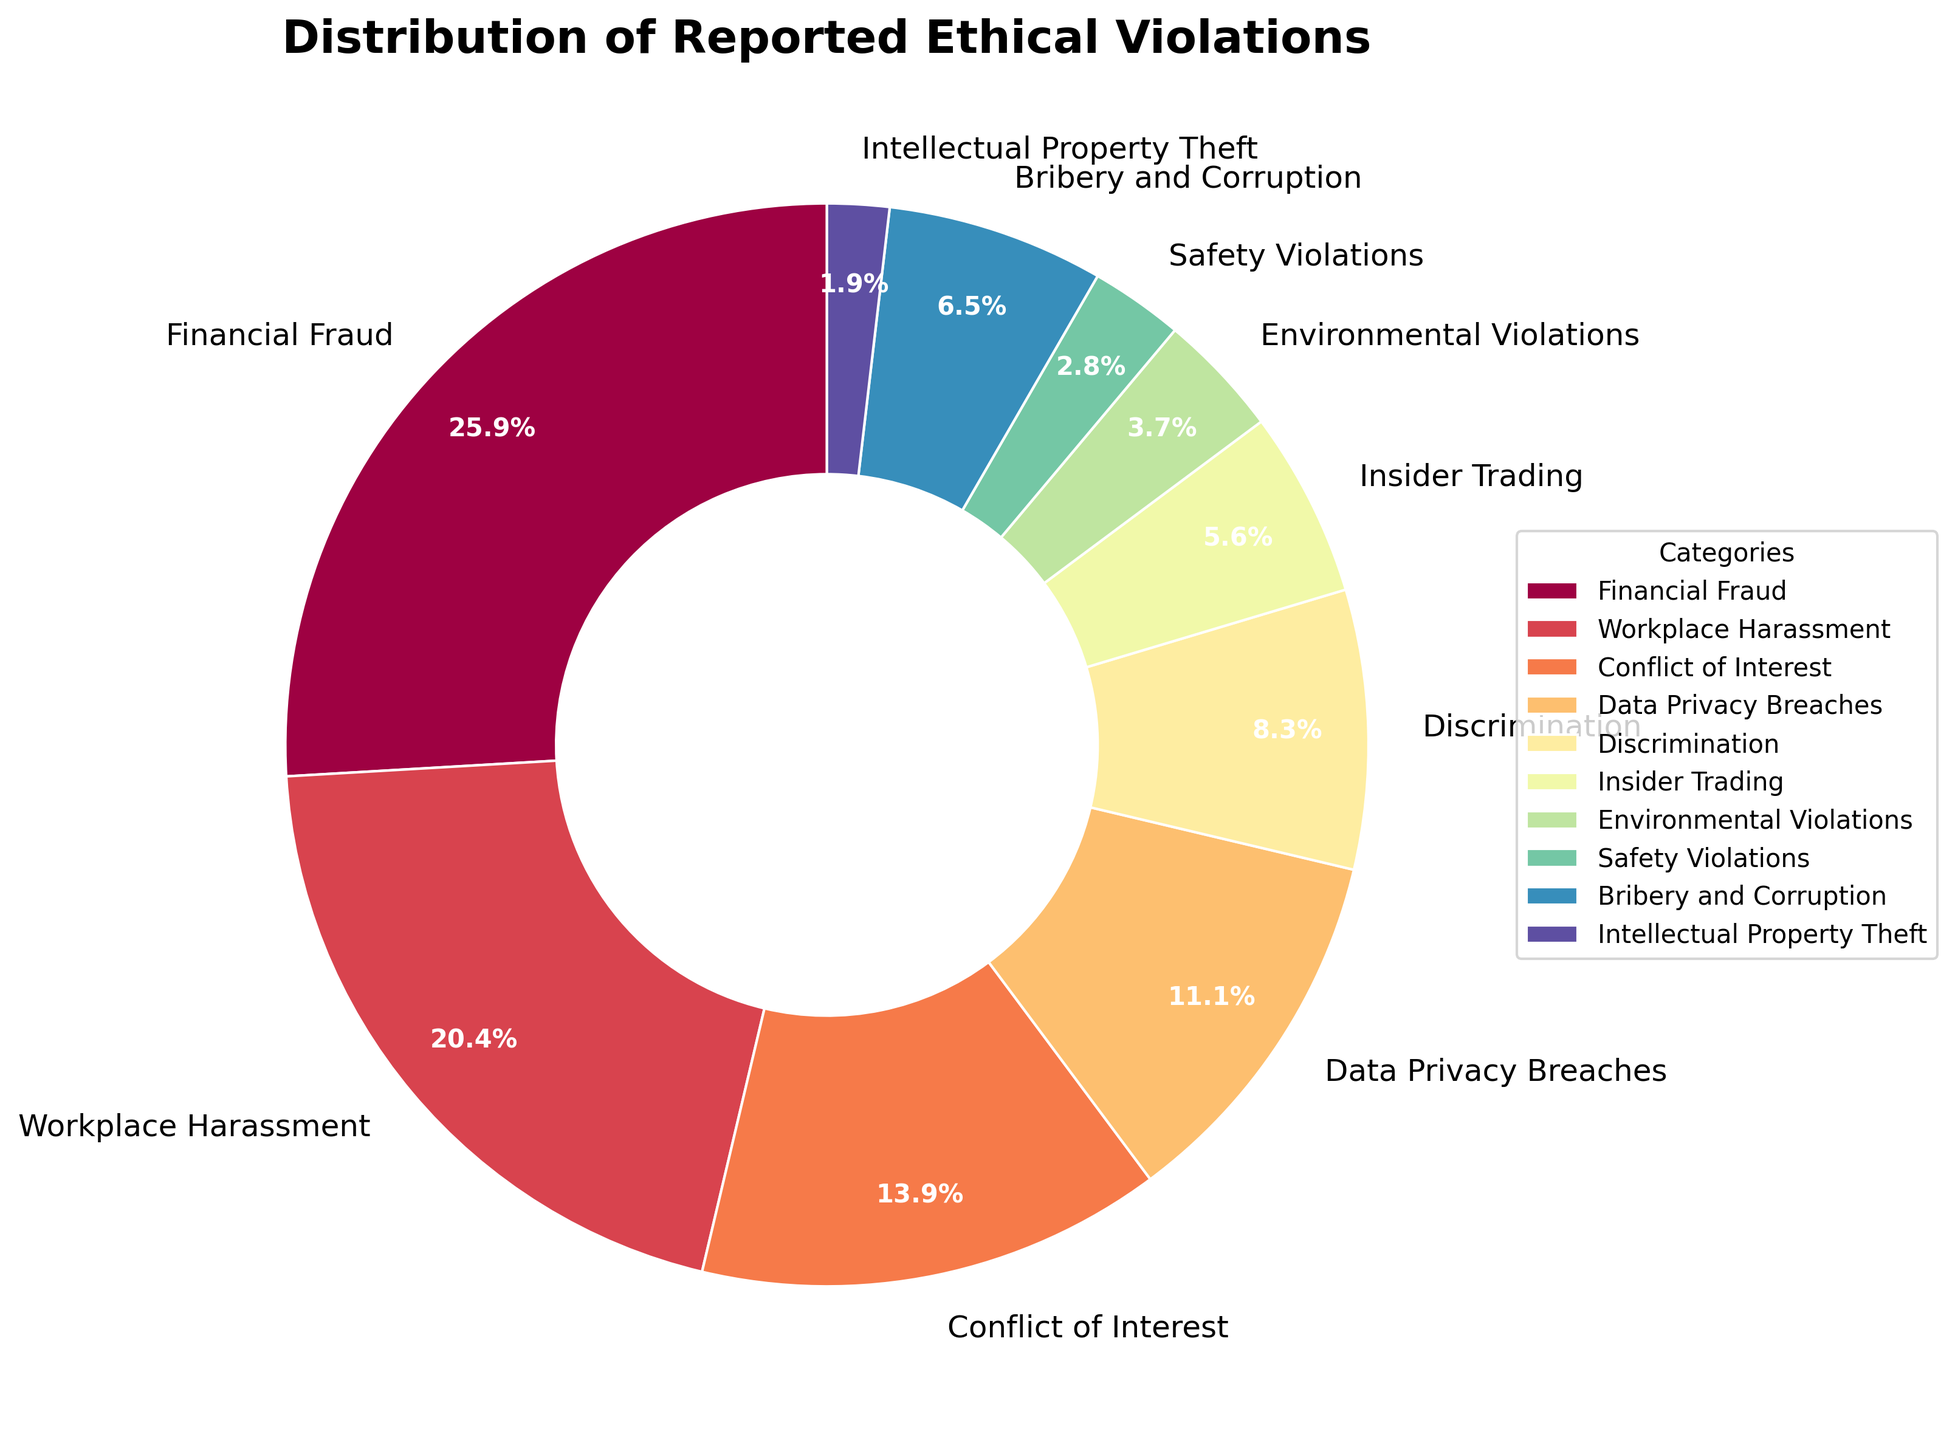What category represents the highest percentage of reported ethical violations? The category with the largest wedge in the pie chart represents the highest percentage. Financial Fraud has the largest wedge.
Answer: Financial Fraud How much more prevalent are Financial Fraud violations compared to Safety Violations? Financial Fraud is at 28% and Safety Violations are at 3%. The difference is 28% - 3% = 25%.
Answer: 25% What are the combined percentages of Workplace Harassment and Conflict of Interest violations? Workplace Harassment is 22% and Conflict of Interest is 15%. Their combined percentage is 22% + 15% = 37%.
Answer: 37% Which category has a similar percentage to Bribery and Corruption? Bribery and Corruption is at 7%. Discrimination is closest at 9%, and Data Privacy Breaches at 12% is not very far off either.
Answer: Discrimination Are Safety Violations or Insider Trading less frequently reported? Safety Violations are 3% and Insider Trading is 6%. Since 3% is less than 6%, Safety Violations are less frequently reported.
Answer: Safety Violations What percentage of total reported violations do the three least reported categories make up? The three least reported categories are Intellectual Property Theft (2%), Safety Violations (3%), and Environmental Violations (4%). Combined, they make up 2% + 3% + 4% = 9%.
Answer: 9% Which two categories together make up around one-third of the reported ethical violations? Financial Fraud at 28% and Bribery and Corruption at 7% together make 28% + 7% = 35%, which is close to one-third (33.3%).
Answer: Financial Fraud and Bribery and Corruption How does the frequency of Workplace Harassment violations compare to Conflict of Interest cases? Workplace Harassment is at 22%, and Conflict of Interest is at 15%. Since 22% is greater than 15%, Workplace Harassment incidents are more frequent.
Answer: Workplace Harassment By how much does Financial Fraud exceed Data Privacy Breaches in terms of reported percentage? Financial Fraud is at 28% and Data Privacy Breaches are at 12%. The difference is 28% - 12% = 16%.
Answer: 16% Which violation category sits between Data Privacy Breaches and Insider Trading in terms of reported frequency? Data Privacy Breaches are at 12% and Insider Trading is at 6%. Bribery and Corruption is at 7%, which sits between these two categories.
Answer: Bribery and Corruption 